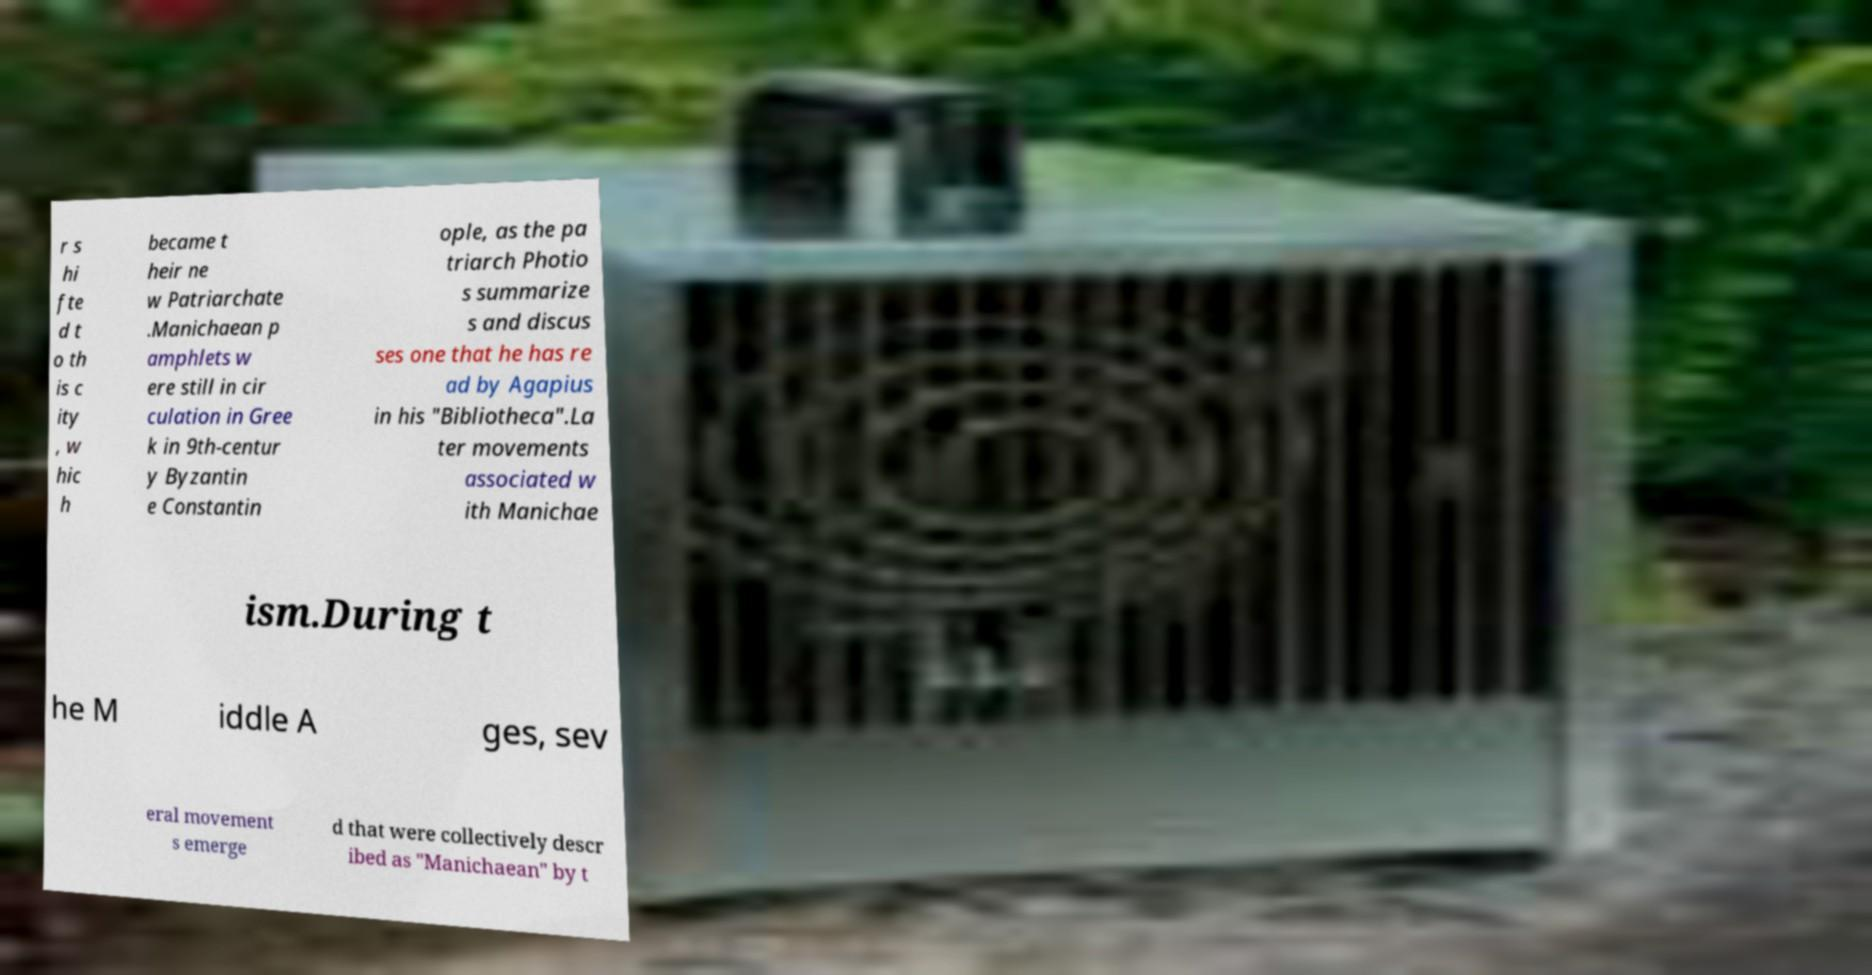Please identify and transcribe the text found in this image. r s hi fte d t o th is c ity , w hic h became t heir ne w Patriarchate .Manichaean p amphlets w ere still in cir culation in Gree k in 9th-centur y Byzantin e Constantin ople, as the pa triarch Photio s summarize s and discus ses one that he has re ad by Agapius in his "Bibliotheca".La ter movements associated w ith Manichae ism.During t he M iddle A ges, sev eral movement s emerge d that were collectively descr ibed as "Manichaean" by t 